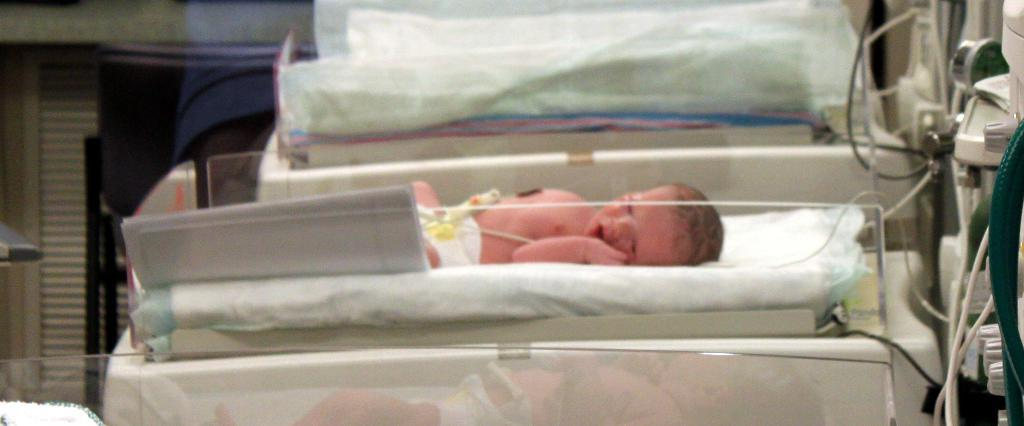What is the main subject of the image? The main subject of the image is a baby. Where is the baby located in the image? The baby is in an incubator. What else can be seen in the image besides the baby? There are cables visible in the image. Are there any other objects present in the image? Yes, there are other objects present in the image. How does the baby stop the brick from falling in the image? There is no brick present in the image, so the baby cannot stop it from falling. 